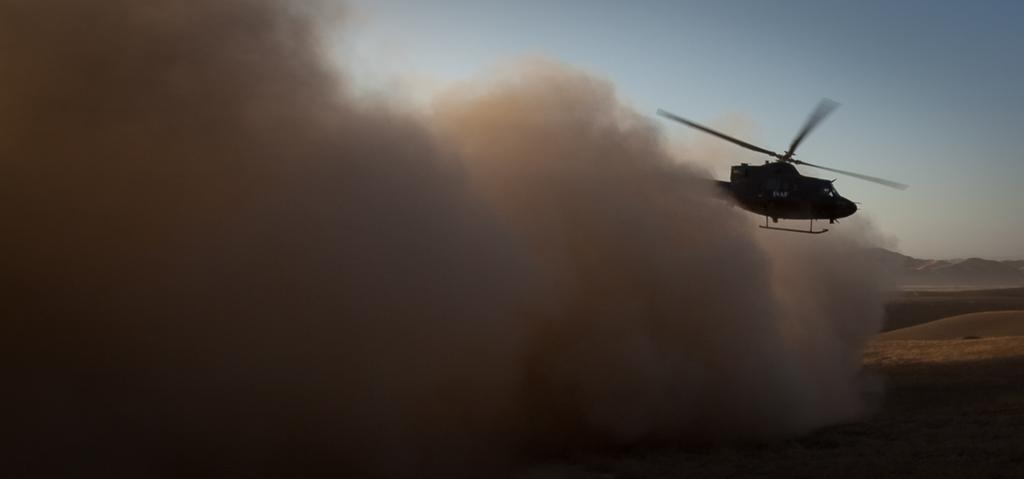What is the main subject of the image? The main subject of the image is a helicopter. What color is the helicopter? The helicopter is black in color. What is the helicopter doing in the image? The helicopter is flying in the air. What can be seen below the helicopter in the image? There is ground visible in the image, and dust is present on the ground. What type of geographical feature is visible in the image? There are mountains in the image. What else can be seen in the sky in the image? The sky is visible in the image. How many visitors can be seen waiting for a haircut in the image? There are no visitors or haircuts present in the image; it features a helicopter flying over mountains and ground. 